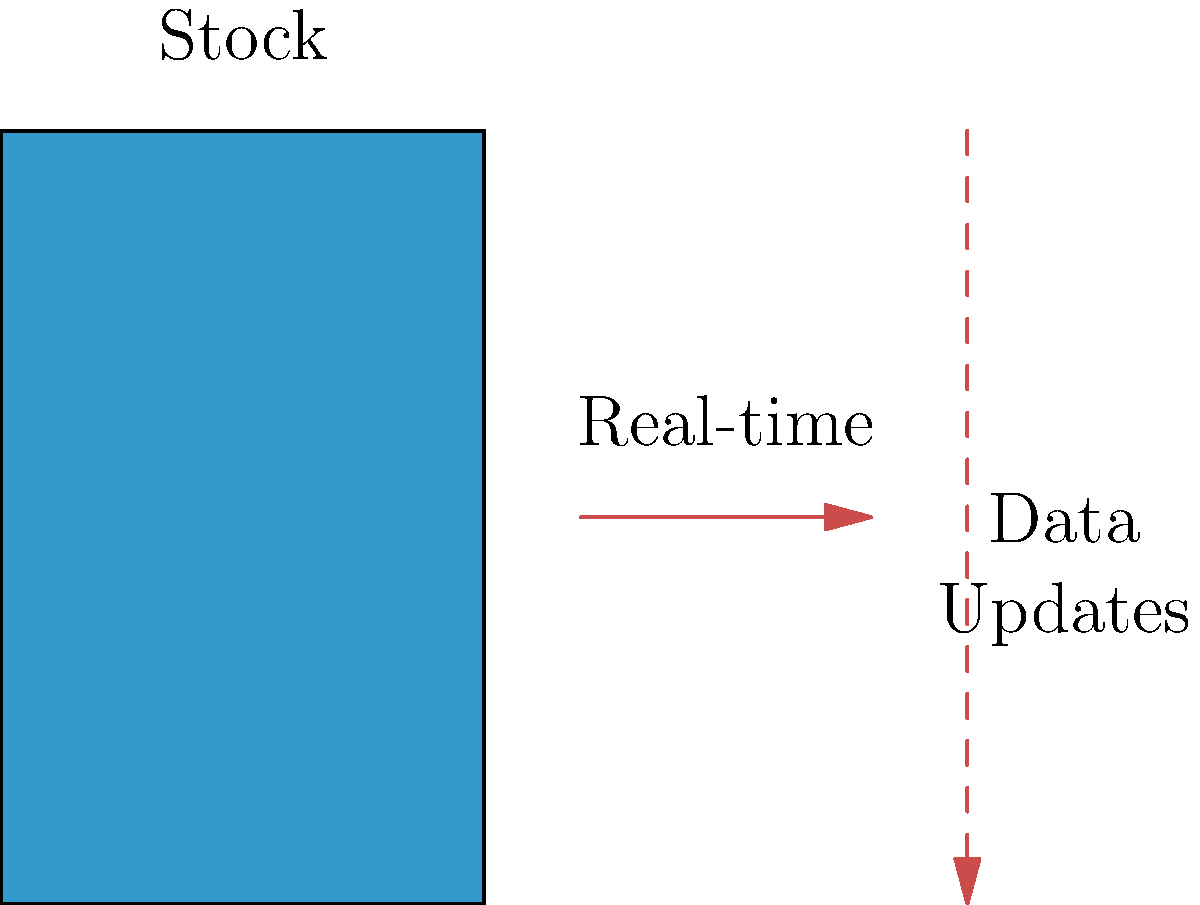As an art director, you're tasked with designing a dynamic infographic that updates stock levels in real-time for a major e-commerce platform. Which key element in the diagram represents the crucial link between the stock visualization and the live data feed, and how would you ensure its effectiveness in the design? To answer this question, let's analyze the diagram and its components:

1. The blue rectangle on the left represents the stock level visualization.
2. The red solid arrow in the middle indicates real-time updates.
3. The red dashed arrow on the right represents the data flow.

The key element linking the stock visualization to the live data feed is the red solid arrow labeled "Real-time". This arrow symbolizes the update mechanism that refreshes the stock level display with new data.

To ensure its effectiveness in the design:

1. Use a contrasting color (like red) to make it stand out from the stock visualization.
2. Implement animation for the arrow to indicate active updating.
3. Place it prominently between the stock visualization and data flow.
4. Consider adding a small icon or text near the arrow to reinforce the real-time nature.
5. Ensure the arrow's size is proportional to other elements for visibility without overwhelming the design.
6. Use consistent styling for all real-time update indicators throughout the infographic.

By emphasizing this element, you communicate to viewers that the stock information is constantly being updated, enhancing the infographic's credibility and usefulness.
Answer: The red solid arrow labeled "Real-time", representing the update mechanism between stock visualization and live data feed. 